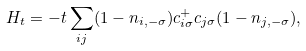<formula> <loc_0><loc_0><loc_500><loc_500>H _ { t } = - t \sum _ { i j } ( 1 - n _ { i , - \sigma } ) c ^ { + } _ { i \sigma } c _ { j \sigma } ( 1 - n _ { j , - \sigma } ) ,</formula> 